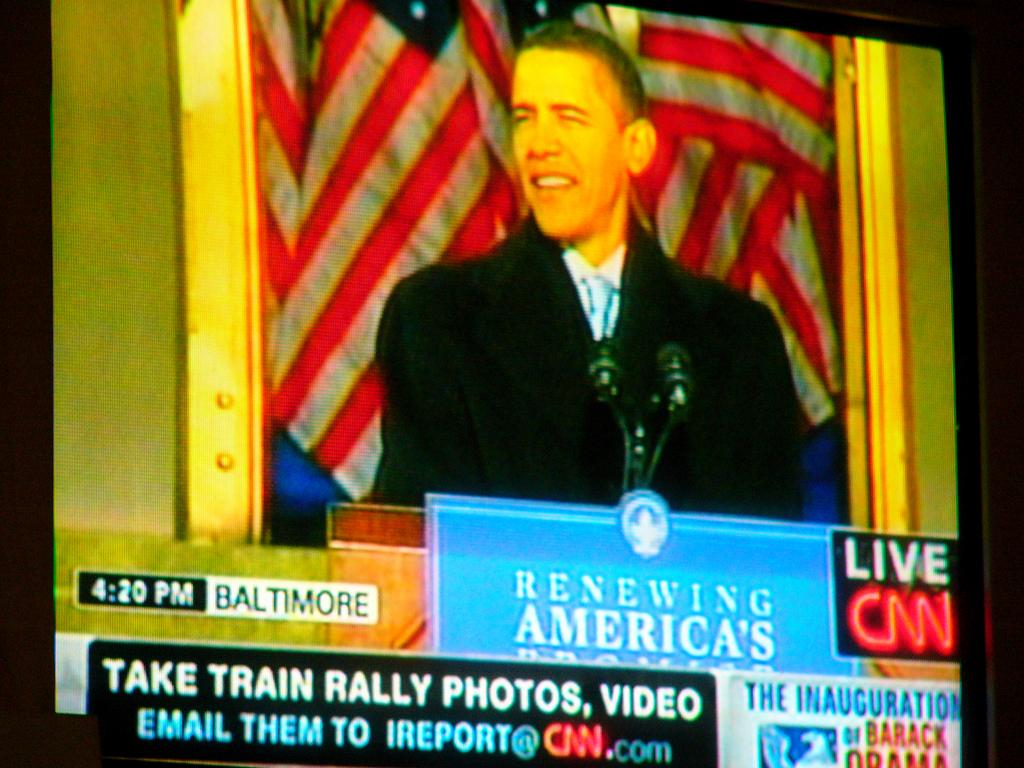<image>
Relay a brief, clear account of the picture shown. The live CNN broadcast of a presidential inauguration. 